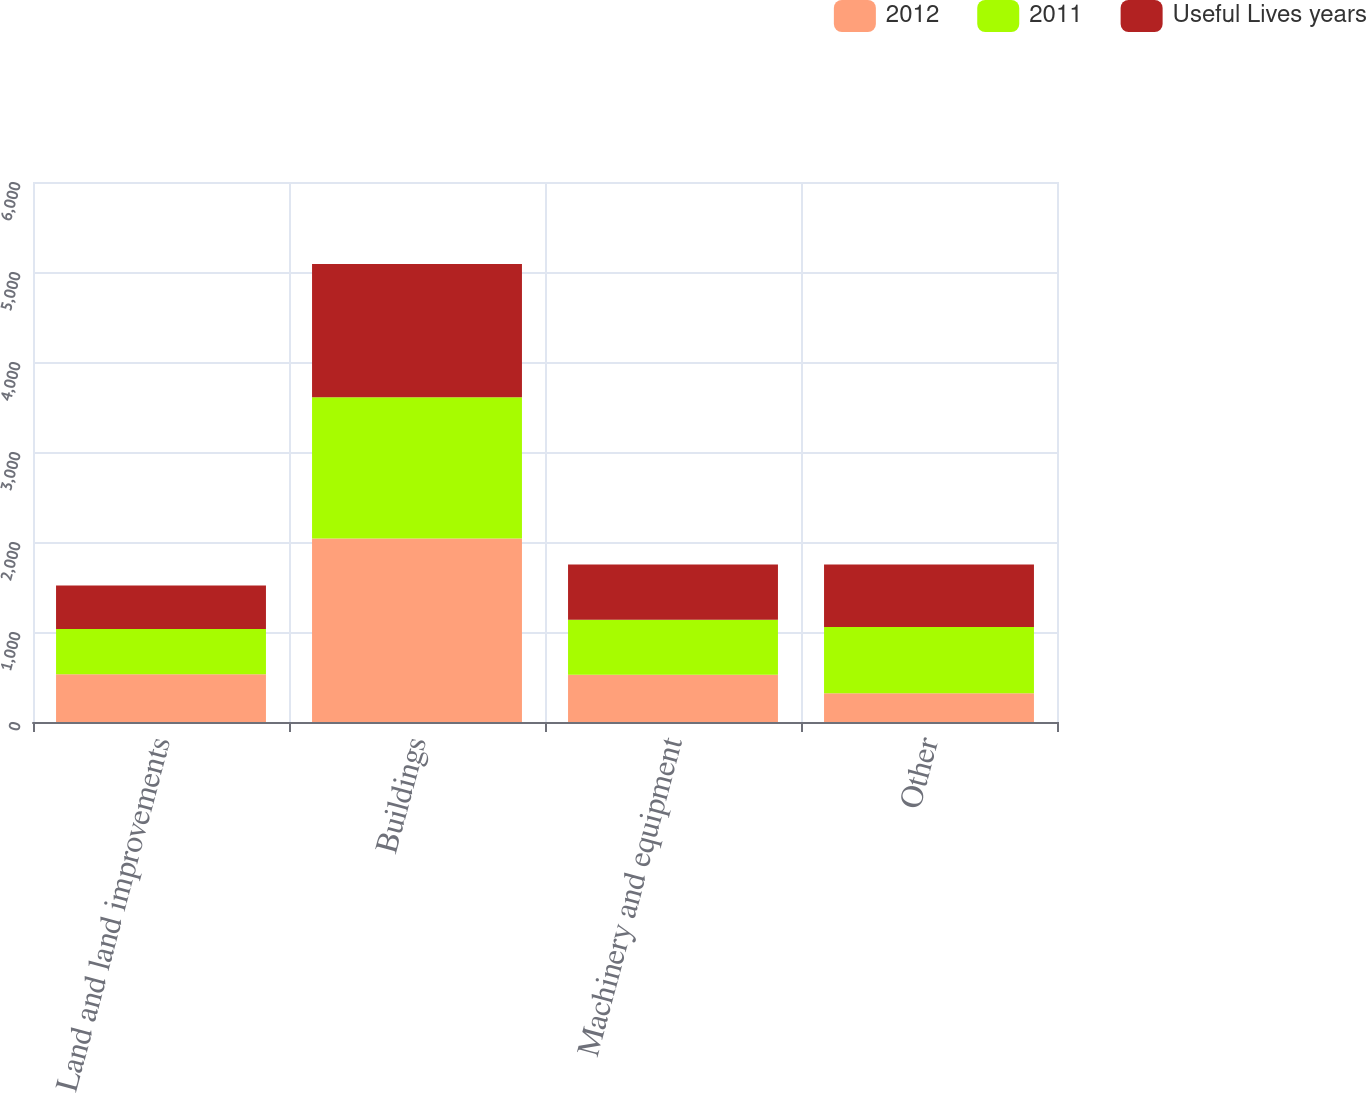Convert chart. <chart><loc_0><loc_0><loc_500><loc_500><stacked_bar_chart><ecel><fcel>Land and land improvements<fcel>Buildings<fcel>Machinery and equipment<fcel>Other<nl><fcel>2012<fcel>530<fcel>2040<fcel>525<fcel>320<nl><fcel>2011<fcel>504<fcel>1568<fcel>612<fcel>735<nl><fcel>Useful Lives years<fcel>482<fcel>1482<fcel>612<fcel>694<nl></chart> 